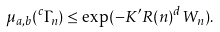<formula> <loc_0><loc_0><loc_500><loc_500>\mu _ { a , b } ( ^ { c } \Gamma _ { n } ) \leq \exp ( - K ^ { \prime } R ( n ) ^ { d } W _ { n } ) .</formula> 